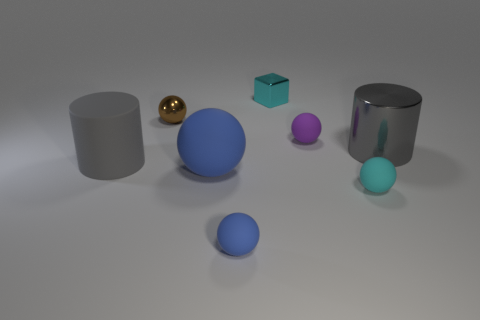There is a small brown thing that is the same shape as the tiny blue matte thing; what material is it?
Provide a succinct answer. Metal. There is a big thing that is the same color as the big matte cylinder; what is its shape?
Make the answer very short. Cylinder. What is the material of the cyan object that is behind the big gray metal object?
Provide a short and direct response. Metal. Is the size of the cyan cube the same as the gray metal cylinder?
Ensure brevity in your answer.  No. Are there more big gray cylinders that are on the right side of the shiny cube than tiny yellow shiny balls?
Keep it short and to the point. Yes. There is a cylinder that is the same material as the tiny purple sphere; what is its size?
Your answer should be compact. Large. Are there any cylinders on the left side of the small metal cube?
Keep it short and to the point. Yes. Does the big gray metallic object have the same shape as the gray rubber object?
Your response must be concise. Yes. There is a cylinder that is right of the small matte sphere that is behind the big gray cylinder that is on the left side of the brown metallic object; what size is it?
Your response must be concise. Large. What is the brown object made of?
Offer a very short reply. Metal. 